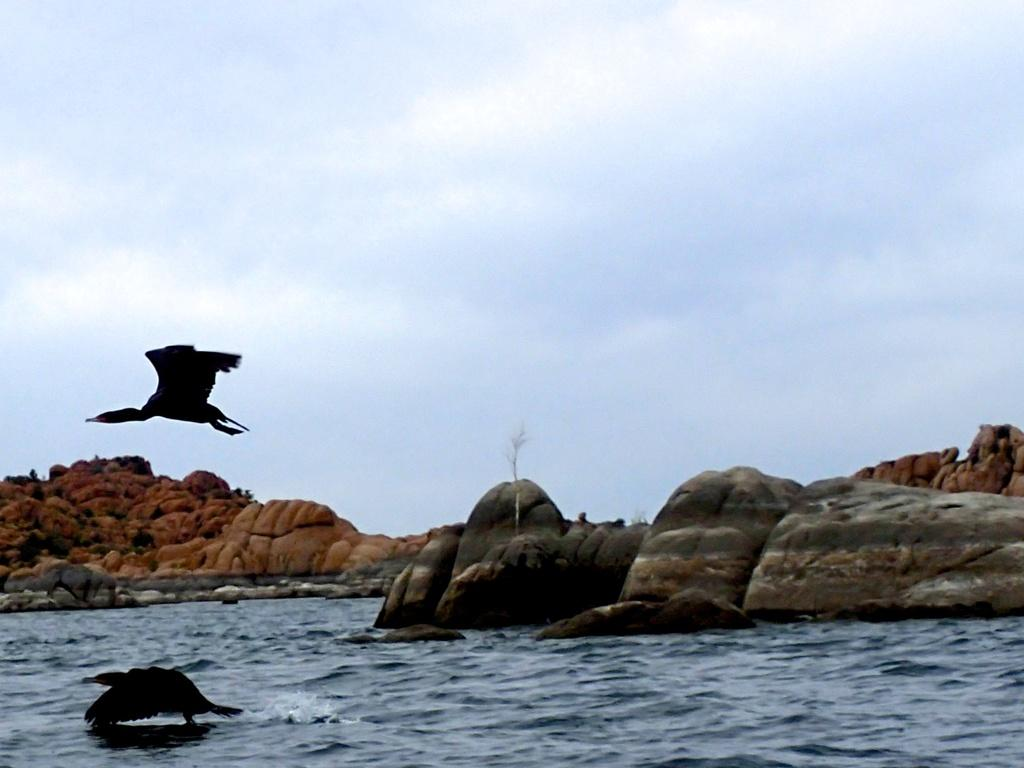How many birds are in the image? There are two birds in the image. What are the birds doing in the image? One bird is flying, and the other bird is in the water. What can be seen in the background of the image? Mountains and the sky are visible in the background of the image. What is the condition of the sky in the image? The sky is visible in the background of the image, and clouds are present. How many cars can be seen in the image? There are no cars present in the image. Are there any spiders visible in the image? There are no spiders visible in the image. 